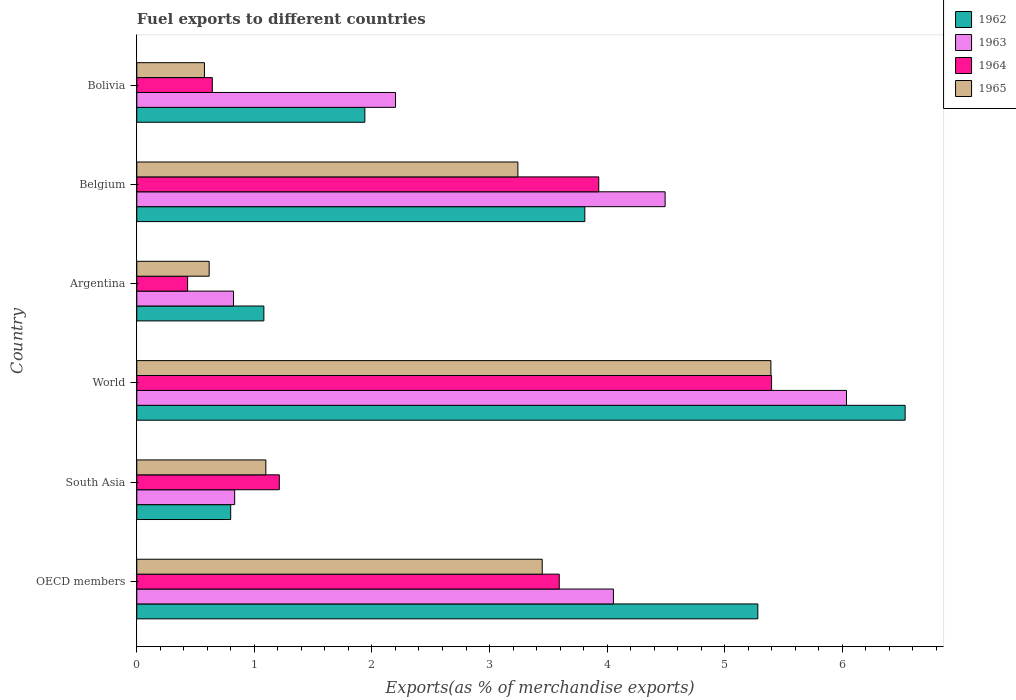How many different coloured bars are there?
Make the answer very short. 4. How many groups of bars are there?
Offer a very short reply. 6. Are the number of bars per tick equal to the number of legend labels?
Offer a terse response. Yes. How many bars are there on the 2nd tick from the top?
Give a very brief answer. 4. What is the label of the 5th group of bars from the top?
Make the answer very short. South Asia. What is the percentage of exports to different countries in 1962 in Bolivia?
Your answer should be very brief. 1.94. Across all countries, what is the maximum percentage of exports to different countries in 1963?
Provide a succinct answer. 6.04. Across all countries, what is the minimum percentage of exports to different countries in 1965?
Give a very brief answer. 0.58. In which country was the percentage of exports to different countries in 1964 minimum?
Your answer should be very brief. Argentina. What is the total percentage of exports to different countries in 1963 in the graph?
Offer a terse response. 18.44. What is the difference between the percentage of exports to different countries in 1962 in Belgium and that in World?
Give a very brief answer. -2.72. What is the difference between the percentage of exports to different countries in 1965 in South Asia and the percentage of exports to different countries in 1963 in Bolivia?
Offer a very short reply. -1.1. What is the average percentage of exports to different countries in 1962 per country?
Your response must be concise. 3.24. What is the difference between the percentage of exports to different countries in 1962 and percentage of exports to different countries in 1964 in OECD members?
Offer a very short reply. 1.69. In how many countries, is the percentage of exports to different countries in 1962 greater than 4.6 %?
Your answer should be compact. 2. What is the ratio of the percentage of exports to different countries in 1963 in Bolivia to that in World?
Offer a very short reply. 0.36. Is the percentage of exports to different countries in 1964 in Belgium less than that in South Asia?
Your answer should be compact. No. What is the difference between the highest and the second highest percentage of exports to different countries in 1965?
Your answer should be compact. 1.94. What is the difference between the highest and the lowest percentage of exports to different countries in 1962?
Provide a succinct answer. 5.74. Is it the case that in every country, the sum of the percentage of exports to different countries in 1964 and percentage of exports to different countries in 1962 is greater than the sum of percentage of exports to different countries in 1963 and percentage of exports to different countries in 1965?
Provide a succinct answer. No. What does the 3rd bar from the top in Bolivia represents?
Make the answer very short. 1963. What does the 3rd bar from the bottom in OECD members represents?
Make the answer very short. 1964. Are all the bars in the graph horizontal?
Your answer should be very brief. Yes. Does the graph contain any zero values?
Keep it short and to the point. No. Where does the legend appear in the graph?
Make the answer very short. Top right. How many legend labels are there?
Offer a terse response. 4. How are the legend labels stacked?
Your response must be concise. Vertical. What is the title of the graph?
Give a very brief answer. Fuel exports to different countries. What is the label or title of the X-axis?
Your answer should be compact. Exports(as % of merchandise exports). What is the label or title of the Y-axis?
Your answer should be compact. Country. What is the Exports(as % of merchandise exports) of 1962 in OECD members?
Your response must be concise. 5.28. What is the Exports(as % of merchandise exports) in 1963 in OECD members?
Offer a very short reply. 4.05. What is the Exports(as % of merchandise exports) in 1964 in OECD members?
Give a very brief answer. 3.59. What is the Exports(as % of merchandise exports) in 1965 in OECD members?
Provide a short and direct response. 3.45. What is the Exports(as % of merchandise exports) of 1962 in South Asia?
Make the answer very short. 0.8. What is the Exports(as % of merchandise exports) in 1963 in South Asia?
Keep it short and to the point. 0.83. What is the Exports(as % of merchandise exports) in 1964 in South Asia?
Give a very brief answer. 1.21. What is the Exports(as % of merchandise exports) of 1965 in South Asia?
Offer a very short reply. 1.1. What is the Exports(as % of merchandise exports) of 1962 in World?
Offer a terse response. 6.53. What is the Exports(as % of merchandise exports) of 1963 in World?
Keep it short and to the point. 6.04. What is the Exports(as % of merchandise exports) in 1964 in World?
Offer a very short reply. 5.4. What is the Exports(as % of merchandise exports) in 1965 in World?
Ensure brevity in your answer.  5.39. What is the Exports(as % of merchandise exports) in 1962 in Argentina?
Your answer should be compact. 1.08. What is the Exports(as % of merchandise exports) of 1963 in Argentina?
Offer a terse response. 0.82. What is the Exports(as % of merchandise exports) of 1964 in Argentina?
Your answer should be very brief. 0.43. What is the Exports(as % of merchandise exports) of 1965 in Argentina?
Offer a very short reply. 0.62. What is the Exports(as % of merchandise exports) of 1962 in Belgium?
Make the answer very short. 3.81. What is the Exports(as % of merchandise exports) in 1963 in Belgium?
Your response must be concise. 4.49. What is the Exports(as % of merchandise exports) of 1964 in Belgium?
Your answer should be very brief. 3.93. What is the Exports(as % of merchandise exports) of 1965 in Belgium?
Keep it short and to the point. 3.24. What is the Exports(as % of merchandise exports) of 1962 in Bolivia?
Provide a short and direct response. 1.94. What is the Exports(as % of merchandise exports) of 1963 in Bolivia?
Your response must be concise. 2.2. What is the Exports(as % of merchandise exports) of 1964 in Bolivia?
Give a very brief answer. 0.64. What is the Exports(as % of merchandise exports) in 1965 in Bolivia?
Provide a short and direct response. 0.58. Across all countries, what is the maximum Exports(as % of merchandise exports) of 1962?
Your answer should be compact. 6.53. Across all countries, what is the maximum Exports(as % of merchandise exports) of 1963?
Keep it short and to the point. 6.04. Across all countries, what is the maximum Exports(as % of merchandise exports) of 1964?
Your answer should be compact. 5.4. Across all countries, what is the maximum Exports(as % of merchandise exports) in 1965?
Give a very brief answer. 5.39. Across all countries, what is the minimum Exports(as % of merchandise exports) in 1962?
Ensure brevity in your answer.  0.8. Across all countries, what is the minimum Exports(as % of merchandise exports) in 1963?
Provide a succinct answer. 0.82. Across all countries, what is the minimum Exports(as % of merchandise exports) of 1964?
Make the answer very short. 0.43. Across all countries, what is the minimum Exports(as % of merchandise exports) of 1965?
Your answer should be compact. 0.58. What is the total Exports(as % of merchandise exports) of 1962 in the graph?
Your response must be concise. 19.45. What is the total Exports(as % of merchandise exports) of 1963 in the graph?
Your response must be concise. 18.44. What is the total Exports(as % of merchandise exports) in 1964 in the graph?
Provide a succinct answer. 15.21. What is the total Exports(as % of merchandise exports) in 1965 in the graph?
Ensure brevity in your answer.  14.37. What is the difference between the Exports(as % of merchandise exports) of 1962 in OECD members and that in South Asia?
Offer a very short reply. 4.48. What is the difference between the Exports(as % of merchandise exports) in 1963 in OECD members and that in South Asia?
Keep it short and to the point. 3.22. What is the difference between the Exports(as % of merchandise exports) of 1964 in OECD members and that in South Asia?
Make the answer very short. 2.38. What is the difference between the Exports(as % of merchandise exports) of 1965 in OECD members and that in South Asia?
Provide a short and direct response. 2.35. What is the difference between the Exports(as % of merchandise exports) in 1962 in OECD members and that in World?
Make the answer very short. -1.25. What is the difference between the Exports(as % of merchandise exports) of 1963 in OECD members and that in World?
Offer a very short reply. -1.98. What is the difference between the Exports(as % of merchandise exports) of 1964 in OECD members and that in World?
Make the answer very short. -1.81. What is the difference between the Exports(as % of merchandise exports) of 1965 in OECD members and that in World?
Ensure brevity in your answer.  -1.94. What is the difference between the Exports(as % of merchandise exports) of 1962 in OECD members and that in Argentina?
Make the answer very short. 4.2. What is the difference between the Exports(as % of merchandise exports) in 1963 in OECD members and that in Argentina?
Keep it short and to the point. 3.23. What is the difference between the Exports(as % of merchandise exports) in 1964 in OECD members and that in Argentina?
Your answer should be very brief. 3.16. What is the difference between the Exports(as % of merchandise exports) in 1965 in OECD members and that in Argentina?
Give a very brief answer. 2.83. What is the difference between the Exports(as % of merchandise exports) of 1962 in OECD members and that in Belgium?
Ensure brevity in your answer.  1.47. What is the difference between the Exports(as % of merchandise exports) of 1963 in OECD members and that in Belgium?
Ensure brevity in your answer.  -0.44. What is the difference between the Exports(as % of merchandise exports) of 1964 in OECD members and that in Belgium?
Ensure brevity in your answer.  -0.34. What is the difference between the Exports(as % of merchandise exports) of 1965 in OECD members and that in Belgium?
Keep it short and to the point. 0.21. What is the difference between the Exports(as % of merchandise exports) in 1962 in OECD members and that in Bolivia?
Your answer should be compact. 3.34. What is the difference between the Exports(as % of merchandise exports) in 1963 in OECD members and that in Bolivia?
Give a very brief answer. 1.85. What is the difference between the Exports(as % of merchandise exports) in 1964 in OECD members and that in Bolivia?
Your response must be concise. 2.95. What is the difference between the Exports(as % of merchandise exports) in 1965 in OECD members and that in Bolivia?
Keep it short and to the point. 2.87. What is the difference between the Exports(as % of merchandise exports) in 1962 in South Asia and that in World?
Ensure brevity in your answer.  -5.74. What is the difference between the Exports(as % of merchandise exports) in 1963 in South Asia and that in World?
Offer a terse response. -5.2. What is the difference between the Exports(as % of merchandise exports) in 1964 in South Asia and that in World?
Your answer should be compact. -4.19. What is the difference between the Exports(as % of merchandise exports) in 1965 in South Asia and that in World?
Your answer should be very brief. -4.3. What is the difference between the Exports(as % of merchandise exports) in 1962 in South Asia and that in Argentina?
Provide a short and direct response. -0.28. What is the difference between the Exports(as % of merchandise exports) of 1963 in South Asia and that in Argentina?
Your answer should be compact. 0.01. What is the difference between the Exports(as % of merchandise exports) of 1964 in South Asia and that in Argentina?
Give a very brief answer. 0.78. What is the difference between the Exports(as % of merchandise exports) of 1965 in South Asia and that in Argentina?
Make the answer very short. 0.48. What is the difference between the Exports(as % of merchandise exports) of 1962 in South Asia and that in Belgium?
Ensure brevity in your answer.  -3.01. What is the difference between the Exports(as % of merchandise exports) of 1963 in South Asia and that in Belgium?
Give a very brief answer. -3.66. What is the difference between the Exports(as % of merchandise exports) of 1964 in South Asia and that in Belgium?
Ensure brevity in your answer.  -2.72. What is the difference between the Exports(as % of merchandise exports) of 1965 in South Asia and that in Belgium?
Provide a succinct answer. -2.14. What is the difference between the Exports(as % of merchandise exports) in 1962 in South Asia and that in Bolivia?
Offer a very short reply. -1.14. What is the difference between the Exports(as % of merchandise exports) of 1963 in South Asia and that in Bolivia?
Ensure brevity in your answer.  -1.37. What is the difference between the Exports(as % of merchandise exports) in 1964 in South Asia and that in Bolivia?
Your answer should be very brief. 0.57. What is the difference between the Exports(as % of merchandise exports) of 1965 in South Asia and that in Bolivia?
Provide a short and direct response. 0.52. What is the difference between the Exports(as % of merchandise exports) of 1962 in World and that in Argentina?
Provide a succinct answer. 5.45. What is the difference between the Exports(as % of merchandise exports) of 1963 in World and that in Argentina?
Make the answer very short. 5.21. What is the difference between the Exports(as % of merchandise exports) in 1964 in World and that in Argentina?
Your answer should be compact. 4.97. What is the difference between the Exports(as % of merchandise exports) in 1965 in World and that in Argentina?
Provide a short and direct response. 4.78. What is the difference between the Exports(as % of merchandise exports) in 1962 in World and that in Belgium?
Offer a terse response. 2.72. What is the difference between the Exports(as % of merchandise exports) in 1963 in World and that in Belgium?
Make the answer very short. 1.54. What is the difference between the Exports(as % of merchandise exports) in 1964 in World and that in Belgium?
Provide a short and direct response. 1.47. What is the difference between the Exports(as % of merchandise exports) of 1965 in World and that in Belgium?
Give a very brief answer. 2.15. What is the difference between the Exports(as % of merchandise exports) in 1962 in World and that in Bolivia?
Provide a succinct answer. 4.59. What is the difference between the Exports(as % of merchandise exports) of 1963 in World and that in Bolivia?
Your answer should be compact. 3.84. What is the difference between the Exports(as % of merchandise exports) in 1964 in World and that in Bolivia?
Your response must be concise. 4.76. What is the difference between the Exports(as % of merchandise exports) in 1965 in World and that in Bolivia?
Make the answer very short. 4.82. What is the difference between the Exports(as % of merchandise exports) in 1962 in Argentina and that in Belgium?
Keep it short and to the point. -2.73. What is the difference between the Exports(as % of merchandise exports) in 1963 in Argentina and that in Belgium?
Make the answer very short. -3.67. What is the difference between the Exports(as % of merchandise exports) in 1964 in Argentina and that in Belgium?
Make the answer very short. -3.5. What is the difference between the Exports(as % of merchandise exports) in 1965 in Argentina and that in Belgium?
Your answer should be compact. -2.63. What is the difference between the Exports(as % of merchandise exports) in 1962 in Argentina and that in Bolivia?
Your answer should be very brief. -0.86. What is the difference between the Exports(as % of merchandise exports) of 1963 in Argentina and that in Bolivia?
Keep it short and to the point. -1.38. What is the difference between the Exports(as % of merchandise exports) in 1964 in Argentina and that in Bolivia?
Provide a succinct answer. -0.21. What is the difference between the Exports(as % of merchandise exports) of 1965 in Argentina and that in Bolivia?
Make the answer very short. 0.04. What is the difference between the Exports(as % of merchandise exports) in 1962 in Belgium and that in Bolivia?
Offer a very short reply. 1.87. What is the difference between the Exports(as % of merchandise exports) of 1963 in Belgium and that in Bolivia?
Your response must be concise. 2.29. What is the difference between the Exports(as % of merchandise exports) in 1964 in Belgium and that in Bolivia?
Make the answer very short. 3.29. What is the difference between the Exports(as % of merchandise exports) in 1965 in Belgium and that in Bolivia?
Provide a short and direct response. 2.67. What is the difference between the Exports(as % of merchandise exports) of 1962 in OECD members and the Exports(as % of merchandise exports) of 1963 in South Asia?
Ensure brevity in your answer.  4.45. What is the difference between the Exports(as % of merchandise exports) in 1962 in OECD members and the Exports(as % of merchandise exports) in 1964 in South Asia?
Your response must be concise. 4.07. What is the difference between the Exports(as % of merchandise exports) of 1962 in OECD members and the Exports(as % of merchandise exports) of 1965 in South Asia?
Ensure brevity in your answer.  4.18. What is the difference between the Exports(as % of merchandise exports) in 1963 in OECD members and the Exports(as % of merchandise exports) in 1964 in South Asia?
Keep it short and to the point. 2.84. What is the difference between the Exports(as % of merchandise exports) of 1963 in OECD members and the Exports(as % of merchandise exports) of 1965 in South Asia?
Your answer should be very brief. 2.96. What is the difference between the Exports(as % of merchandise exports) in 1964 in OECD members and the Exports(as % of merchandise exports) in 1965 in South Asia?
Offer a terse response. 2.5. What is the difference between the Exports(as % of merchandise exports) of 1962 in OECD members and the Exports(as % of merchandise exports) of 1963 in World?
Give a very brief answer. -0.75. What is the difference between the Exports(as % of merchandise exports) in 1962 in OECD members and the Exports(as % of merchandise exports) in 1964 in World?
Provide a short and direct response. -0.12. What is the difference between the Exports(as % of merchandise exports) of 1962 in OECD members and the Exports(as % of merchandise exports) of 1965 in World?
Provide a succinct answer. -0.11. What is the difference between the Exports(as % of merchandise exports) of 1963 in OECD members and the Exports(as % of merchandise exports) of 1964 in World?
Make the answer very short. -1.35. What is the difference between the Exports(as % of merchandise exports) of 1963 in OECD members and the Exports(as % of merchandise exports) of 1965 in World?
Give a very brief answer. -1.34. What is the difference between the Exports(as % of merchandise exports) of 1964 in OECD members and the Exports(as % of merchandise exports) of 1965 in World?
Offer a very short reply. -1.8. What is the difference between the Exports(as % of merchandise exports) in 1962 in OECD members and the Exports(as % of merchandise exports) in 1963 in Argentina?
Make the answer very short. 4.46. What is the difference between the Exports(as % of merchandise exports) in 1962 in OECD members and the Exports(as % of merchandise exports) in 1964 in Argentina?
Your response must be concise. 4.85. What is the difference between the Exports(as % of merchandise exports) of 1962 in OECD members and the Exports(as % of merchandise exports) of 1965 in Argentina?
Make the answer very short. 4.67. What is the difference between the Exports(as % of merchandise exports) of 1963 in OECD members and the Exports(as % of merchandise exports) of 1964 in Argentina?
Your response must be concise. 3.62. What is the difference between the Exports(as % of merchandise exports) in 1963 in OECD members and the Exports(as % of merchandise exports) in 1965 in Argentina?
Give a very brief answer. 3.44. What is the difference between the Exports(as % of merchandise exports) in 1964 in OECD members and the Exports(as % of merchandise exports) in 1965 in Argentina?
Your response must be concise. 2.98. What is the difference between the Exports(as % of merchandise exports) in 1962 in OECD members and the Exports(as % of merchandise exports) in 1963 in Belgium?
Your response must be concise. 0.79. What is the difference between the Exports(as % of merchandise exports) in 1962 in OECD members and the Exports(as % of merchandise exports) in 1964 in Belgium?
Your response must be concise. 1.35. What is the difference between the Exports(as % of merchandise exports) of 1962 in OECD members and the Exports(as % of merchandise exports) of 1965 in Belgium?
Your answer should be very brief. 2.04. What is the difference between the Exports(as % of merchandise exports) of 1963 in OECD members and the Exports(as % of merchandise exports) of 1964 in Belgium?
Your response must be concise. 0.12. What is the difference between the Exports(as % of merchandise exports) in 1963 in OECD members and the Exports(as % of merchandise exports) in 1965 in Belgium?
Give a very brief answer. 0.81. What is the difference between the Exports(as % of merchandise exports) in 1964 in OECD members and the Exports(as % of merchandise exports) in 1965 in Belgium?
Offer a terse response. 0.35. What is the difference between the Exports(as % of merchandise exports) of 1962 in OECD members and the Exports(as % of merchandise exports) of 1963 in Bolivia?
Provide a succinct answer. 3.08. What is the difference between the Exports(as % of merchandise exports) of 1962 in OECD members and the Exports(as % of merchandise exports) of 1964 in Bolivia?
Your answer should be very brief. 4.64. What is the difference between the Exports(as % of merchandise exports) of 1962 in OECD members and the Exports(as % of merchandise exports) of 1965 in Bolivia?
Offer a terse response. 4.71. What is the difference between the Exports(as % of merchandise exports) of 1963 in OECD members and the Exports(as % of merchandise exports) of 1964 in Bolivia?
Provide a short and direct response. 3.41. What is the difference between the Exports(as % of merchandise exports) of 1963 in OECD members and the Exports(as % of merchandise exports) of 1965 in Bolivia?
Give a very brief answer. 3.48. What is the difference between the Exports(as % of merchandise exports) in 1964 in OECD members and the Exports(as % of merchandise exports) in 1965 in Bolivia?
Give a very brief answer. 3.02. What is the difference between the Exports(as % of merchandise exports) of 1962 in South Asia and the Exports(as % of merchandise exports) of 1963 in World?
Your response must be concise. -5.24. What is the difference between the Exports(as % of merchandise exports) of 1962 in South Asia and the Exports(as % of merchandise exports) of 1964 in World?
Your answer should be very brief. -4.6. What is the difference between the Exports(as % of merchandise exports) in 1962 in South Asia and the Exports(as % of merchandise exports) in 1965 in World?
Ensure brevity in your answer.  -4.59. What is the difference between the Exports(as % of merchandise exports) of 1963 in South Asia and the Exports(as % of merchandise exports) of 1964 in World?
Your answer should be very brief. -4.57. What is the difference between the Exports(as % of merchandise exports) of 1963 in South Asia and the Exports(as % of merchandise exports) of 1965 in World?
Offer a very short reply. -4.56. What is the difference between the Exports(as % of merchandise exports) of 1964 in South Asia and the Exports(as % of merchandise exports) of 1965 in World?
Make the answer very short. -4.18. What is the difference between the Exports(as % of merchandise exports) of 1962 in South Asia and the Exports(as % of merchandise exports) of 1963 in Argentina?
Make the answer very short. -0.02. What is the difference between the Exports(as % of merchandise exports) of 1962 in South Asia and the Exports(as % of merchandise exports) of 1964 in Argentina?
Make the answer very short. 0.37. What is the difference between the Exports(as % of merchandise exports) of 1962 in South Asia and the Exports(as % of merchandise exports) of 1965 in Argentina?
Keep it short and to the point. 0.18. What is the difference between the Exports(as % of merchandise exports) in 1963 in South Asia and the Exports(as % of merchandise exports) in 1964 in Argentina?
Give a very brief answer. 0.4. What is the difference between the Exports(as % of merchandise exports) in 1963 in South Asia and the Exports(as % of merchandise exports) in 1965 in Argentina?
Your answer should be compact. 0.22. What is the difference between the Exports(as % of merchandise exports) of 1964 in South Asia and the Exports(as % of merchandise exports) of 1965 in Argentina?
Provide a succinct answer. 0.6. What is the difference between the Exports(as % of merchandise exports) in 1962 in South Asia and the Exports(as % of merchandise exports) in 1963 in Belgium?
Your answer should be compact. -3.69. What is the difference between the Exports(as % of merchandise exports) in 1962 in South Asia and the Exports(as % of merchandise exports) in 1964 in Belgium?
Offer a very short reply. -3.13. What is the difference between the Exports(as % of merchandise exports) in 1962 in South Asia and the Exports(as % of merchandise exports) in 1965 in Belgium?
Provide a short and direct response. -2.44. What is the difference between the Exports(as % of merchandise exports) of 1963 in South Asia and the Exports(as % of merchandise exports) of 1964 in Belgium?
Give a very brief answer. -3.1. What is the difference between the Exports(as % of merchandise exports) in 1963 in South Asia and the Exports(as % of merchandise exports) in 1965 in Belgium?
Offer a very short reply. -2.41. What is the difference between the Exports(as % of merchandise exports) of 1964 in South Asia and the Exports(as % of merchandise exports) of 1965 in Belgium?
Your response must be concise. -2.03. What is the difference between the Exports(as % of merchandise exports) in 1962 in South Asia and the Exports(as % of merchandise exports) in 1963 in Bolivia?
Provide a short and direct response. -1.4. What is the difference between the Exports(as % of merchandise exports) of 1962 in South Asia and the Exports(as % of merchandise exports) of 1964 in Bolivia?
Provide a short and direct response. 0.16. What is the difference between the Exports(as % of merchandise exports) of 1962 in South Asia and the Exports(as % of merchandise exports) of 1965 in Bolivia?
Your answer should be very brief. 0.22. What is the difference between the Exports(as % of merchandise exports) in 1963 in South Asia and the Exports(as % of merchandise exports) in 1964 in Bolivia?
Your response must be concise. 0.19. What is the difference between the Exports(as % of merchandise exports) of 1963 in South Asia and the Exports(as % of merchandise exports) of 1965 in Bolivia?
Offer a very short reply. 0.26. What is the difference between the Exports(as % of merchandise exports) of 1964 in South Asia and the Exports(as % of merchandise exports) of 1965 in Bolivia?
Ensure brevity in your answer.  0.64. What is the difference between the Exports(as % of merchandise exports) of 1962 in World and the Exports(as % of merchandise exports) of 1963 in Argentina?
Offer a terse response. 5.71. What is the difference between the Exports(as % of merchandise exports) in 1962 in World and the Exports(as % of merchandise exports) in 1964 in Argentina?
Give a very brief answer. 6.1. What is the difference between the Exports(as % of merchandise exports) in 1962 in World and the Exports(as % of merchandise exports) in 1965 in Argentina?
Offer a very short reply. 5.92. What is the difference between the Exports(as % of merchandise exports) of 1963 in World and the Exports(as % of merchandise exports) of 1964 in Argentina?
Offer a very short reply. 5.6. What is the difference between the Exports(as % of merchandise exports) in 1963 in World and the Exports(as % of merchandise exports) in 1965 in Argentina?
Your response must be concise. 5.42. What is the difference between the Exports(as % of merchandise exports) of 1964 in World and the Exports(as % of merchandise exports) of 1965 in Argentina?
Provide a succinct answer. 4.78. What is the difference between the Exports(as % of merchandise exports) in 1962 in World and the Exports(as % of merchandise exports) in 1963 in Belgium?
Keep it short and to the point. 2.04. What is the difference between the Exports(as % of merchandise exports) of 1962 in World and the Exports(as % of merchandise exports) of 1964 in Belgium?
Your response must be concise. 2.61. What is the difference between the Exports(as % of merchandise exports) in 1962 in World and the Exports(as % of merchandise exports) in 1965 in Belgium?
Your answer should be compact. 3.29. What is the difference between the Exports(as % of merchandise exports) of 1963 in World and the Exports(as % of merchandise exports) of 1964 in Belgium?
Your response must be concise. 2.11. What is the difference between the Exports(as % of merchandise exports) of 1963 in World and the Exports(as % of merchandise exports) of 1965 in Belgium?
Offer a very short reply. 2.79. What is the difference between the Exports(as % of merchandise exports) of 1964 in World and the Exports(as % of merchandise exports) of 1965 in Belgium?
Your answer should be compact. 2.16. What is the difference between the Exports(as % of merchandise exports) of 1962 in World and the Exports(as % of merchandise exports) of 1963 in Bolivia?
Your answer should be very brief. 4.33. What is the difference between the Exports(as % of merchandise exports) of 1962 in World and the Exports(as % of merchandise exports) of 1964 in Bolivia?
Give a very brief answer. 5.89. What is the difference between the Exports(as % of merchandise exports) in 1962 in World and the Exports(as % of merchandise exports) in 1965 in Bolivia?
Make the answer very short. 5.96. What is the difference between the Exports(as % of merchandise exports) in 1963 in World and the Exports(as % of merchandise exports) in 1964 in Bolivia?
Your answer should be compact. 5.39. What is the difference between the Exports(as % of merchandise exports) in 1963 in World and the Exports(as % of merchandise exports) in 1965 in Bolivia?
Your response must be concise. 5.46. What is the difference between the Exports(as % of merchandise exports) of 1964 in World and the Exports(as % of merchandise exports) of 1965 in Bolivia?
Give a very brief answer. 4.82. What is the difference between the Exports(as % of merchandise exports) of 1962 in Argentina and the Exports(as % of merchandise exports) of 1963 in Belgium?
Give a very brief answer. -3.41. What is the difference between the Exports(as % of merchandise exports) in 1962 in Argentina and the Exports(as % of merchandise exports) in 1964 in Belgium?
Keep it short and to the point. -2.85. What is the difference between the Exports(as % of merchandise exports) in 1962 in Argentina and the Exports(as % of merchandise exports) in 1965 in Belgium?
Your response must be concise. -2.16. What is the difference between the Exports(as % of merchandise exports) of 1963 in Argentina and the Exports(as % of merchandise exports) of 1964 in Belgium?
Your response must be concise. -3.11. What is the difference between the Exports(as % of merchandise exports) in 1963 in Argentina and the Exports(as % of merchandise exports) in 1965 in Belgium?
Provide a short and direct response. -2.42. What is the difference between the Exports(as % of merchandise exports) in 1964 in Argentina and the Exports(as % of merchandise exports) in 1965 in Belgium?
Make the answer very short. -2.81. What is the difference between the Exports(as % of merchandise exports) of 1962 in Argentina and the Exports(as % of merchandise exports) of 1963 in Bolivia?
Provide a succinct answer. -1.12. What is the difference between the Exports(as % of merchandise exports) in 1962 in Argentina and the Exports(as % of merchandise exports) in 1964 in Bolivia?
Your answer should be very brief. 0.44. What is the difference between the Exports(as % of merchandise exports) in 1962 in Argentina and the Exports(as % of merchandise exports) in 1965 in Bolivia?
Offer a terse response. 0.51. What is the difference between the Exports(as % of merchandise exports) of 1963 in Argentina and the Exports(as % of merchandise exports) of 1964 in Bolivia?
Offer a terse response. 0.18. What is the difference between the Exports(as % of merchandise exports) of 1963 in Argentina and the Exports(as % of merchandise exports) of 1965 in Bolivia?
Offer a very short reply. 0.25. What is the difference between the Exports(as % of merchandise exports) of 1964 in Argentina and the Exports(as % of merchandise exports) of 1965 in Bolivia?
Provide a succinct answer. -0.14. What is the difference between the Exports(as % of merchandise exports) in 1962 in Belgium and the Exports(as % of merchandise exports) in 1963 in Bolivia?
Your answer should be compact. 1.61. What is the difference between the Exports(as % of merchandise exports) in 1962 in Belgium and the Exports(as % of merchandise exports) in 1964 in Bolivia?
Give a very brief answer. 3.17. What is the difference between the Exports(as % of merchandise exports) of 1962 in Belgium and the Exports(as % of merchandise exports) of 1965 in Bolivia?
Offer a very short reply. 3.23. What is the difference between the Exports(as % of merchandise exports) of 1963 in Belgium and the Exports(as % of merchandise exports) of 1964 in Bolivia?
Make the answer very short. 3.85. What is the difference between the Exports(as % of merchandise exports) in 1963 in Belgium and the Exports(as % of merchandise exports) in 1965 in Bolivia?
Make the answer very short. 3.92. What is the difference between the Exports(as % of merchandise exports) of 1964 in Belgium and the Exports(as % of merchandise exports) of 1965 in Bolivia?
Provide a succinct answer. 3.35. What is the average Exports(as % of merchandise exports) in 1962 per country?
Make the answer very short. 3.24. What is the average Exports(as % of merchandise exports) of 1963 per country?
Keep it short and to the point. 3.07. What is the average Exports(as % of merchandise exports) in 1964 per country?
Your answer should be very brief. 2.53. What is the average Exports(as % of merchandise exports) in 1965 per country?
Make the answer very short. 2.4. What is the difference between the Exports(as % of merchandise exports) in 1962 and Exports(as % of merchandise exports) in 1963 in OECD members?
Your answer should be very brief. 1.23. What is the difference between the Exports(as % of merchandise exports) of 1962 and Exports(as % of merchandise exports) of 1964 in OECD members?
Provide a succinct answer. 1.69. What is the difference between the Exports(as % of merchandise exports) in 1962 and Exports(as % of merchandise exports) in 1965 in OECD members?
Your answer should be compact. 1.83. What is the difference between the Exports(as % of merchandise exports) in 1963 and Exports(as % of merchandise exports) in 1964 in OECD members?
Provide a succinct answer. 0.46. What is the difference between the Exports(as % of merchandise exports) in 1963 and Exports(as % of merchandise exports) in 1965 in OECD members?
Your response must be concise. 0.61. What is the difference between the Exports(as % of merchandise exports) of 1964 and Exports(as % of merchandise exports) of 1965 in OECD members?
Offer a terse response. 0.14. What is the difference between the Exports(as % of merchandise exports) of 1962 and Exports(as % of merchandise exports) of 1963 in South Asia?
Offer a very short reply. -0.03. What is the difference between the Exports(as % of merchandise exports) of 1962 and Exports(as % of merchandise exports) of 1964 in South Asia?
Make the answer very short. -0.41. What is the difference between the Exports(as % of merchandise exports) in 1962 and Exports(as % of merchandise exports) in 1965 in South Asia?
Give a very brief answer. -0.3. What is the difference between the Exports(as % of merchandise exports) of 1963 and Exports(as % of merchandise exports) of 1964 in South Asia?
Keep it short and to the point. -0.38. What is the difference between the Exports(as % of merchandise exports) in 1963 and Exports(as % of merchandise exports) in 1965 in South Asia?
Your response must be concise. -0.27. What is the difference between the Exports(as % of merchandise exports) of 1964 and Exports(as % of merchandise exports) of 1965 in South Asia?
Make the answer very short. 0.11. What is the difference between the Exports(as % of merchandise exports) in 1962 and Exports(as % of merchandise exports) in 1963 in World?
Your response must be concise. 0.5. What is the difference between the Exports(as % of merchandise exports) of 1962 and Exports(as % of merchandise exports) of 1964 in World?
Offer a very short reply. 1.14. What is the difference between the Exports(as % of merchandise exports) in 1962 and Exports(as % of merchandise exports) in 1965 in World?
Make the answer very short. 1.14. What is the difference between the Exports(as % of merchandise exports) in 1963 and Exports(as % of merchandise exports) in 1964 in World?
Your response must be concise. 0.64. What is the difference between the Exports(as % of merchandise exports) of 1963 and Exports(as % of merchandise exports) of 1965 in World?
Offer a terse response. 0.64. What is the difference between the Exports(as % of merchandise exports) of 1964 and Exports(as % of merchandise exports) of 1965 in World?
Provide a short and direct response. 0.01. What is the difference between the Exports(as % of merchandise exports) of 1962 and Exports(as % of merchandise exports) of 1963 in Argentina?
Offer a terse response. 0.26. What is the difference between the Exports(as % of merchandise exports) of 1962 and Exports(as % of merchandise exports) of 1964 in Argentina?
Provide a succinct answer. 0.65. What is the difference between the Exports(as % of merchandise exports) in 1962 and Exports(as % of merchandise exports) in 1965 in Argentina?
Offer a terse response. 0.47. What is the difference between the Exports(as % of merchandise exports) in 1963 and Exports(as % of merchandise exports) in 1964 in Argentina?
Give a very brief answer. 0.39. What is the difference between the Exports(as % of merchandise exports) in 1963 and Exports(as % of merchandise exports) in 1965 in Argentina?
Make the answer very short. 0.21. What is the difference between the Exports(as % of merchandise exports) of 1964 and Exports(as % of merchandise exports) of 1965 in Argentina?
Make the answer very short. -0.18. What is the difference between the Exports(as % of merchandise exports) in 1962 and Exports(as % of merchandise exports) in 1963 in Belgium?
Your answer should be very brief. -0.68. What is the difference between the Exports(as % of merchandise exports) in 1962 and Exports(as % of merchandise exports) in 1964 in Belgium?
Make the answer very short. -0.12. What is the difference between the Exports(as % of merchandise exports) in 1962 and Exports(as % of merchandise exports) in 1965 in Belgium?
Keep it short and to the point. 0.57. What is the difference between the Exports(as % of merchandise exports) in 1963 and Exports(as % of merchandise exports) in 1964 in Belgium?
Give a very brief answer. 0.56. What is the difference between the Exports(as % of merchandise exports) of 1963 and Exports(as % of merchandise exports) of 1965 in Belgium?
Provide a short and direct response. 1.25. What is the difference between the Exports(as % of merchandise exports) of 1964 and Exports(as % of merchandise exports) of 1965 in Belgium?
Offer a terse response. 0.69. What is the difference between the Exports(as % of merchandise exports) of 1962 and Exports(as % of merchandise exports) of 1963 in Bolivia?
Provide a short and direct response. -0.26. What is the difference between the Exports(as % of merchandise exports) of 1962 and Exports(as % of merchandise exports) of 1964 in Bolivia?
Ensure brevity in your answer.  1.3. What is the difference between the Exports(as % of merchandise exports) in 1962 and Exports(as % of merchandise exports) in 1965 in Bolivia?
Make the answer very short. 1.36. What is the difference between the Exports(as % of merchandise exports) in 1963 and Exports(as % of merchandise exports) in 1964 in Bolivia?
Your answer should be compact. 1.56. What is the difference between the Exports(as % of merchandise exports) in 1963 and Exports(as % of merchandise exports) in 1965 in Bolivia?
Your response must be concise. 1.62. What is the difference between the Exports(as % of merchandise exports) in 1964 and Exports(as % of merchandise exports) in 1965 in Bolivia?
Your answer should be compact. 0.07. What is the ratio of the Exports(as % of merchandise exports) in 1962 in OECD members to that in South Asia?
Offer a very short reply. 6.61. What is the ratio of the Exports(as % of merchandise exports) in 1963 in OECD members to that in South Asia?
Your answer should be compact. 4.87. What is the ratio of the Exports(as % of merchandise exports) in 1964 in OECD members to that in South Asia?
Your response must be concise. 2.96. What is the ratio of the Exports(as % of merchandise exports) in 1965 in OECD members to that in South Asia?
Your answer should be compact. 3.14. What is the ratio of the Exports(as % of merchandise exports) in 1962 in OECD members to that in World?
Offer a very short reply. 0.81. What is the ratio of the Exports(as % of merchandise exports) of 1963 in OECD members to that in World?
Make the answer very short. 0.67. What is the ratio of the Exports(as % of merchandise exports) in 1964 in OECD members to that in World?
Your response must be concise. 0.67. What is the ratio of the Exports(as % of merchandise exports) of 1965 in OECD members to that in World?
Your answer should be compact. 0.64. What is the ratio of the Exports(as % of merchandise exports) in 1962 in OECD members to that in Argentina?
Ensure brevity in your answer.  4.89. What is the ratio of the Exports(as % of merchandise exports) of 1963 in OECD members to that in Argentina?
Keep it short and to the point. 4.93. What is the ratio of the Exports(as % of merchandise exports) of 1964 in OECD members to that in Argentina?
Provide a short and direct response. 8.31. What is the ratio of the Exports(as % of merchandise exports) of 1965 in OECD members to that in Argentina?
Offer a terse response. 5.6. What is the ratio of the Exports(as % of merchandise exports) in 1962 in OECD members to that in Belgium?
Your answer should be compact. 1.39. What is the ratio of the Exports(as % of merchandise exports) of 1963 in OECD members to that in Belgium?
Your answer should be very brief. 0.9. What is the ratio of the Exports(as % of merchandise exports) of 1964 in OECD members to that in Belgium?
Offer a very short reply. 0.91. What is the ratio of the Exports(as % of merchandise exports) of 1965 in OECD members to that in Belgium?
Provide a short and direct response. 1.06. What is the ratio of the Exports(as % of merchandise exports) of 1962 in OECD members to that in Bolivia?
Keep it short and to the point. 2.72. What is the ratio of the Exports(as % of merchandise exports) in 1963 in OECD members to that in Bolivia?
Your response must be concise. 1.84. What is the ratio of the Exports(as % of merchandise exports) in 1964 in OECD members to that in Bolivia?
Your response must be concise. 5.59. What is the ratio of the Exports(as % of merchandise exports) of 1965 in OECD members to that in Bolivia?
Keep it short and to the point. 5.99. What is the ratio of the Exports(as % of merchandise exports) of 1962 in South Asia to that in World?
Offer a terse response. 0.12. What is the ratio of the Exports(as % of merchandise exports) of 1963 in South Asia to that in World?
Provide a short and direct response. 0.14. What is the ratio of the Exports(as % of merchandise exports) of 1964 in South Asia to that in World?
Offer a very short reply. 0.22. What is the ratio of the Exports(as % of merchandise exports) in 1965 in South Asia to that in World?
Your answer should be compact. 0.2. What is the ratio of the Exports(as % of merchandise exports) in 1962 in South Asia to that in Argentina?
Give a very brief answer. 0.74. What is the ratio of the Exports(as % of merchandise exports) of 1963 in South Asia to that in Argentina?
Provide a short and direct response. 1.01. What is the ratio of the Exports(as % of merchandise exports) in 1964 in South Asia to that in Argentina?
Offer a terse response. 2.8. What is the ratio of the Exports(as % of merchandise exports) in 1965 in South Asia to that in Argentina?
Make the answer very short. 1.78. What is the ratio of the Exports(as % of merchandise exports) of 1962 in South Asia to that in Belgium?
Give a very brief answer. 0.21. What is the ratio of the Exports(as % of merchandise exports) of 1963 in South Asia to that in Belgium?
Ensure brevity in your answer.  0.19. What is the ratio of the Exports(as % of merchandise exports) in 1964 in South Asia to that in Belgium?
Your answer should be compact. 0.31. What is the ratio of the Exports(as % of merchandise exports) in 1965 in South Asia to that in Belgium?
Ensure brevity in your answer.  0.34. What is the ratio of the Exports(as % of merchandise exports) in 1962 in South Asia to that in Bolivia?
Offer a terse response. 0.41. What is the ratio of the Exports(as % of merchandise exports) in 1963 in South Asia to that in Bolivia?
Keep it short and to the point. 0.38. What is the ratio of the Exports(as % of merchandise exports) of 1964 in South Asia to that in Bolivia?
Keep it short and to the point. 1.89. What is the ratio of the Exports(as % of merchandise exports) in 1965 in South Asia to that in Bolivia?
Your answer should be compact. 1.91. What is the ratio of the Exports(as % of merchandise exports) of 1962 in World to that in Argentina?
Give a very brief answer. 6.05. What is the ratio of the Exports(as % of merchandise exports) in 1963 in World to that in Argentina?
Provide a short and direct response. 7.34. What is the ratio of the Exports(as % of merchandise exports) of 1964 in World to that in Argentina?
Offer a very short reply. 12.49. What is the ratio of the Exports(as % of merchandise exports) in 1965 in World to that in Argentina?
Your answer should be very brief. 8.76. What is the ratio of the Exports(as % of merchandise exports) of 1962 in World to that in Belgium?
Keep it short and to the point. 1.72. What is the ratio of the Exports(as % of merchandise exports) of 1963 in World to that in Belgium?
Provide a short and direct response. 1.34. What is the ratio of the Exports(as % of merchandise exports) of 1964 in World to that in Belgium?
Provide a short and direct response. 1.37. What is the ratio of the Exports(as % of merchandise exports) in 1965 in World to that in Belgium?
Your response must be concise. 1.66. What is the ratio of the Exports(as % of merchandise exports) of 1962 in World to that in Bolivia?
Provide a succinct answer. 3.37. What is the ratio of the Exports(as % of merchandise exports) of 1963 in World to that in Bolivia?
Provide a succinct answer. 2.74. What is the ratio of the Exports(as % of merchandise exports) of 1964 in World to that in Bolivia?
Provide a succinct answer. 8.4. What is the ratio of the Exports(as % of merchandise exports) of 1965 in World to that in Bolivia?
Ensure brevity in your answer.  9.37. What is the ratio of the Exports(as % of merchandise exports) in 1962 in Argentina to that in Belgium?
Give a very brief answer. 0.28. What is the ratio of the Exports(as % of merchandise exports) in 1963 in Argentina to that in Belgium?
Offer a terse response. 0.18. What is the ratio of the Exports(as % of merchandise exports) in 1964 in Argentina to that in Belgium?
Your answer should be very brief. 0.11. What is the ratio of the Exports(as % of merchandise exports) in 1965 in Argentina to that in Belgium?
Provide a succinct answer. 0.19. What is the ratio of the Exports(as % of merchandise exports) of 1962 in Argentina to that in Bolivia?
Provide a succinct answer. 0.56. What is the ratio of the Exports(as % of merchandise exports) in 1963 in Argentina to that in Bolivia?
Offer a very short reply. 0.37. What is the ratio of the Exports(as % of merchandise exports) in 1964 in Argentina to that in Bolivia?
Ensure brevity in your answer.  0.67. What is the ratio of the Exports(as % of merchandise exports) of 1965 in Argentina to that in Bolivia?
Keep it short and to the point. 1.07. What is the ratio of the Exports(as % of merchandise exports) in 1962 in Belgium to that in Bolivia?
Ensure brevity in your answer.  1.96. What is the ratio of the Exports(as % of merchandise exports) of 1963 in Belgium to that in Bolivia?
Your answer should be very brief. 2.04. What is the ratio of the Exports(as % of merchandise exports) in 1964 in Belgium to that in Bolivia?
Your response must be concise. 6.12. What is the ratio of the Exports(as % of merchandise exports) in 1965 in Belgium to that in Bolivia?
Make the answer very short. 5.63. What is the difference between the highest and the second highest Exports(as % of merchandise exports) of 1962?
Make the answer very short. 1.25. What is the difference between the highest and the second highest Exports(as % of merchandise exports) of 1963?
Your answer should be compact. 1.54. What is the difference between the highest and the second highest Exports(as % of merchandise exports) in 1964?
Give a very brief answer. 1.47. What is the difference between the highest and the second highest Exports(as % of merchandise exports) of 1965?
Your response must be concise. 1.94. What is the difference between the highest and the lowest Exports(as % of merchandise exports) in 1962?
Your response must be concise. 5.74. What is the difference between the highest and the lowest Exports(as % of merchandise exports) in 1963?
Your response must be concise. 5.21. What is the difference between the highest and the lowest Exports(as % of merchandise exports) of 1964?
Keep it short and to the point. 4.97. What is the difference between the highest and the lowest Exports(as % of merchandise exports) in 1965?
Your answer should be compact. 4.82. 